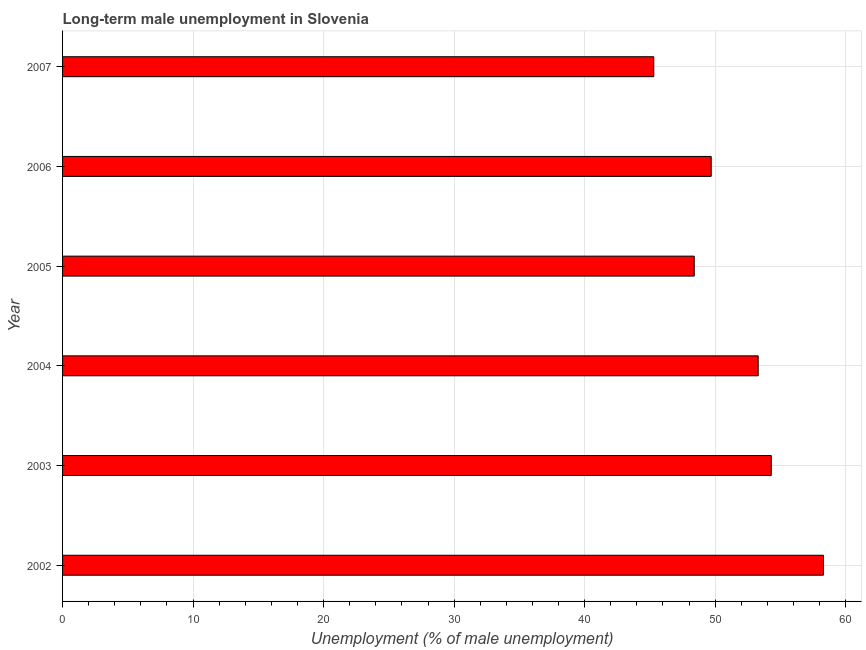What is the title of the graph?
Make the answer very short. Long-term male unemployment in Slovenia. What is the label or title of the X-axis?
Ensure brevity in your answer.  Unemployment (% of male unemployment). What is the long-term male unemployment in 2007?
Ensure brevity in your answer.  45.3. Across all years, what is the maximum long-term male unemployment?
Offer a very short reply. 58.3. Across all years, what is the minimum long-term male unemployment?
Your response must be concise. 45.3. What is the sum of the long-term male unemployment?
Offer a very short reply. 309.3. What is the difference between the long-term male unemployment in 2006 and 2007?
Your answer should be very brief. 4.4. What is the average long-term male unemployment per year?
Offer a terse response. 51.55. What is the median long-term male unemployment?
Offer a very short reply. 51.5. What is the ratio of the long-term male unemployment in 2003 to that in 2005?
Your answer should be compact. 1.12. Is the long-term male unemployment in 2002 less than that in 2007?
Your answer should be very brief. No. What is the difference between the highest and the second highest long-term male unemployment?
Your answer should be compact. 4. Is the sum of the long-term male unemployment in 2002 and 2005 greater than the maximum long-term male unemployment across all years?
Your answer should be compact. Yes. How many bars are there?
Give a very brief answer. 6. Are all the bars in the graph horizontal?
Keep it short and to the point. Yes. How many years are there in the graph?
Keep it short and to the point. 6. Are the values on the major ticks of X-axis written in scientific E-notation?
Provide a short and direct response. No. What is the Unemployment (% of male unemployment) in 2002?
Your answer should be compact. 58.3. What is the Unemployment (% of male unemployment) in 2003?
Your answer should be compact. 54.3. What is the Unemployment (% of male unemployment) in 2004?
Your answer should be very brief. 53.3. What is the Unemployment (% of male unemployment) in 2005?
Keep it short and to the point. 48.4. What is the Unemployment (% of male unemployment) in 2006?
Your answer should be compact. 49.7. What is the Unemployment (% of male unemployment) of 2007?
Your response must be concise. 45.3. What is the difference between the Unemployment (% of male unemployment) in 2002 and 2005?
Make the answer very short. 9.9. What is the difference between the Unemployment (% of male unemployment) in 2002 and 2007?
Offer a very short reply. 13. What is the difference between the Unemployment (% of male unemployment) in 2003 and 2004?
Ensure brevity in your answer.  1. What is the difference between the Unemployment (% of male unemployment) in 2003 and 2005?
Ensure brevity in your answer.  5.9. What is the difference between the Unemployment (% of male unemployment) in 2003 and 2006?
Give a very brief answer. 4.6. What is the difference between the Unemployment (% of male unemployment) in 2003 and 2007?
Provide a succinct answer. 9. What is the difference between the Unemployment (% of male unemployment) in 2004 and 2006?
Provide a short and direct response. 3.6. What is the difference between the Unemployment (% of male unemployment) in 2004 and 2007?
Provide a short and direct response. 8. What is the difference between the Unemployment (% of male unemployment) in 2005 and 2006?
Your answer should be very brief. -1.3. What is the difference between the Unemployment (% of male unemployment) in 2005 and 2007?
Your answer should be very brief. 3.1. What is the ratio of the Unemployment (% of male unemployment) in 2002 to that in 2003?
Provide a short and direct response. 1.07. What is the ratio of the Unemployment (% of male unemployment) in 2002 to that in 2004?
Offer a very short reply. 1.09. What is the ratio of the Unemployment (% of male unemployment) in 2002 to that in 2005?
Your answer should be very brief. 1.21. What is the ratio of the Unemployment (% of male unemployment) in 2002 to that in 2006?
Ensure brevity in your answer.  1.17. What is the ratio of the Unemployment (% of male unemployment) in 2002 to that in 2007?
Offer a very short reply. 1.29. What is the ratio of the Unemployment (% of male unemployment) in 2003 to that in 2005?
Offer a terse response. 1.12. What is the ratio of the Unemployment (% of male unemployment) in 2003 to that in 2006?
Offer a terse response. 1.09. What is the ratio of the Unemployment (% of male unemployment) in 2003 to that in 2007?
Your response must be concise. 1.2. What is the ratio of the Unemployment (% of male unemployment) in 2004 to that in 2005?
Your answer should be compact. 1.1. What is the ratio of the Unemployment (% of male unemployment) in 2004 to that in 2006?
Your response must be concise. 1.07. What is the ratio of the Unemployment (% of male unemployment) in 2004 to that in 2007?
Offer a very short reply. 1.18. What is the ratio of the Unemployment (% of male unemployment) in 2005 to that in 2006?
Your answer should be very brief. 0.97. What is the ratio of the Unemployment (% of male unemployment) in 2005 to that in 2007?
Ensure brevity in your answer.  1.07. What is the ratio of the Unemployment (% of male unemployment) in 2006 to that in 2007?
Make the answer very short. 1.1. 